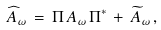<formula> <loc_0><loc_0><loc_500><loc_500>\widehat { A } _ { \omega } \, = \, \Pi \, A _ { \omega } \, \Pi ^ { * } \, + \, \widetilde { A } _ { \omega } \, ,</formula> 